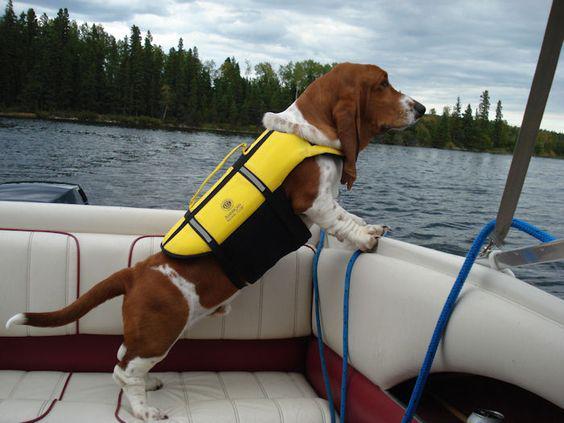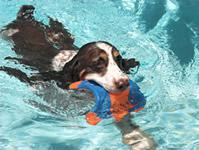The first image is the image on the left, the second image is the image on the right. Analyze the images presented: Is the assertion "In one of the images there is a Basset Hound wearing sunglasses." valid? Answer yes or no. No. 